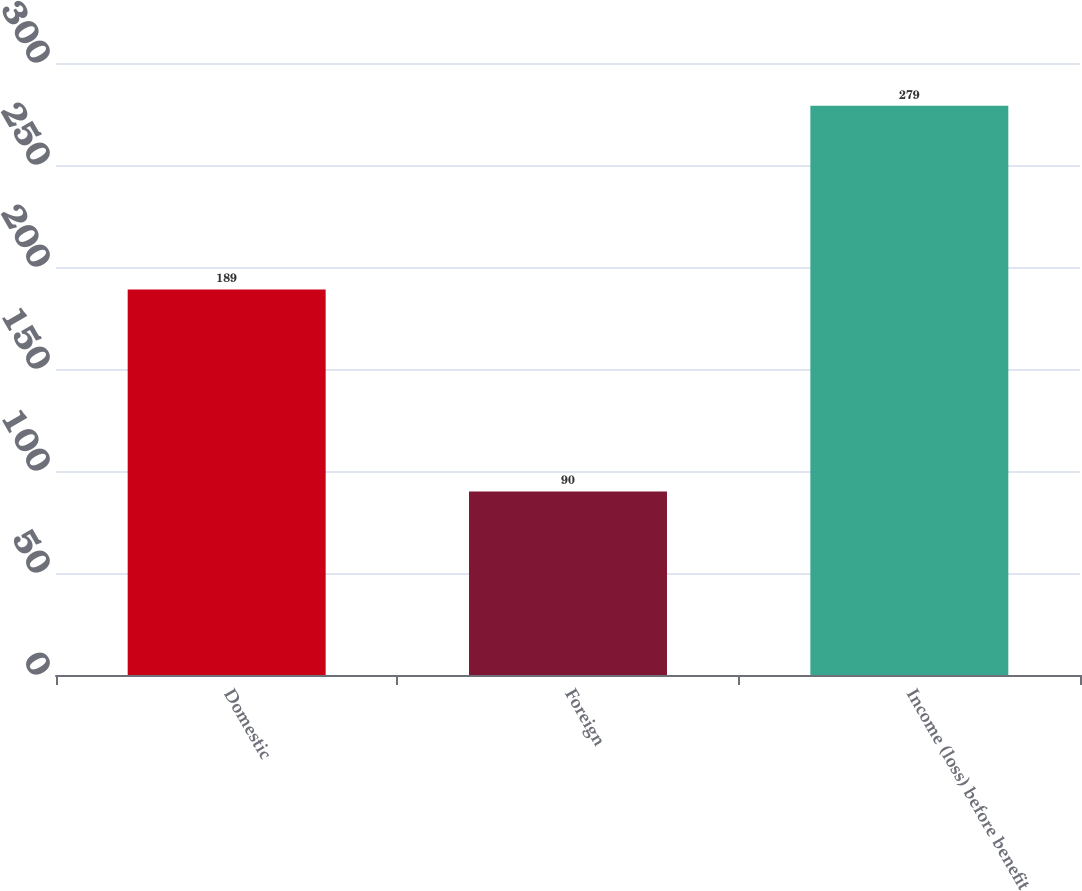Convert chart. <chart><loc_0><loc_0><loc_500><loc_500><bar_chart><fcel>Domestic<fcel>Foreign<fcel>Income (loss) before benefit<nl><fcel>189<fcel>90<fcel>279<nl></chart> 